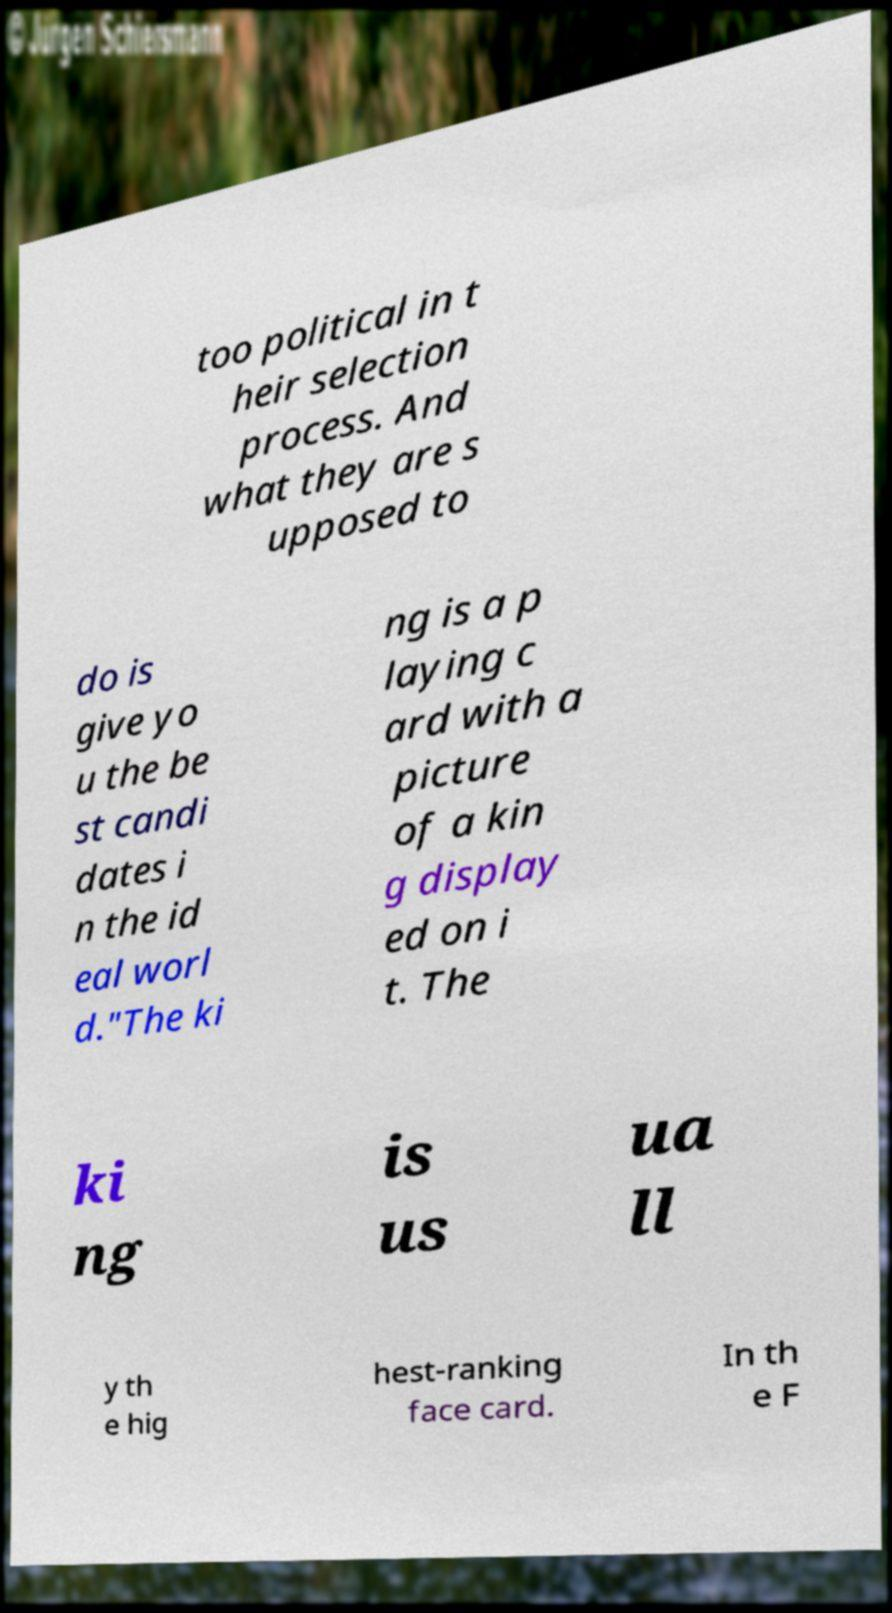Please identify and transcribe the text found in this image. too political in t heir selection process. And what they are s upposed to do is give yo u the be st candi dates i n the id eal worl d."The ki ng is a p laying c ard with a picture of a kin g display ed on i t. The ki ng is us ua ll y th e hig hest-ranking face card. In th e F 